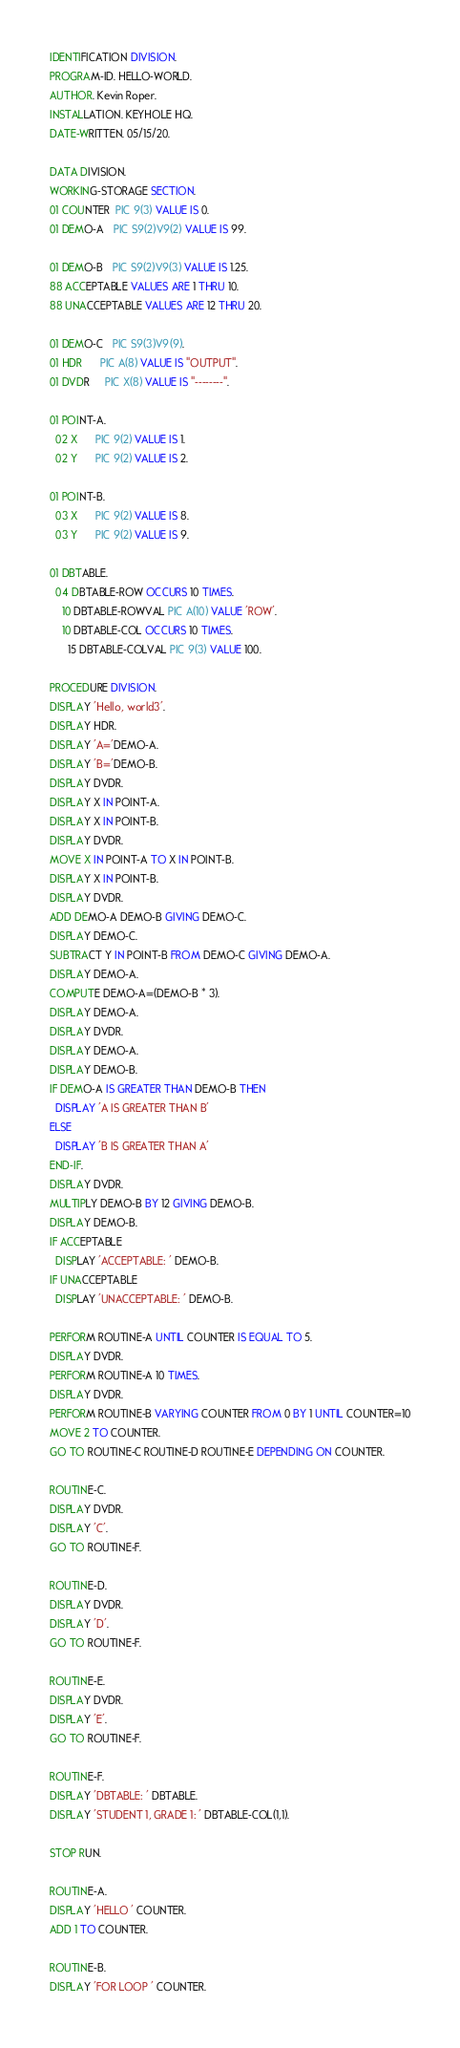Convert code to text. <code><loc_0><loc_0><loc_500><loc_500><_COBOL_>IDENTIFICATION DIVISION.
PROGRAM-ID. HELLO-WORLD.
AUTHOR. Kevin Roper.
INSTALLATION. KEYHOLE HQ.
DATE-WRITTEN. 05/15/20.

DATA DIVISION.
WORKING-STORAGE SECTION.
01 COUNTER  PIC 9(3) VALUE IS 0.
01 DEMO-A   PIC S9(2)V9(2) VALUE IS 99.

01 DEMO-B   PIC S9(2)V9(3) VALUE IS 1.25.
88 ACCEPTABLE VALUES ARE 1 THRU 10.
88 UNACCEPTABLE VALUES ARE 12 THRU 20.

01 DEMO-C   PIC S9(3)V9(9).
01 HDR      PIC A(8) VALUE IS "OUTPUT".
01 DVDR     PIC X(8) VALUE IS "--------".

01 POINT-A.
  02 X      PIC 9(2) VALUE IS 1.
  02 Y      PIC 9(2) VALUE IS 2.

01 POINT-B.
  03 X      PIC 9(2) VALUE IS 8.
  03 Y      PIC 9(2) VALUE IS 9.

01 DBTABLE.
  04 DBTABLE-ROW OCCURS 10 TIMES.
    10 DBTABLE-ROWVAL PIC A(10) VALUE 'ROW'.
    10 DBTABLE-COL OCCURS 10 TIMES.
      15 DBTABLE-COLVAL PIC 9(3) VALUE 100.

PROCEDURE DIVISION.
DISPLAY 'Hello, world3'.
DISPLAY HDR.
DISPLAY 'A='DEMO-A.
DISPLAY 'B='DEMO-B.
DISPLAY DVDR.
DISPLAY X IN POINT-A.
DISPLAY X IN POINT-B.
DISPLAY DVDR.
MOVE X IN POINT-A TO X IN POINT-B.
DISPLAY X IN POINT-B.
DISPLAY DVDR.
ADD DEMO-A DEMO-B GIVING DEMO-C.
DISPLAY DEMO-C.
SUBTRACT Y IN POINT-B FROM DEMO-C GIVING DEMO-A.
DISPLAY DEMO-A.
COMPUTE DEMO-A=(DEMO-B * 3).
DISPLAY DEMO-A.
DISPLAY DVDR.
DISPLAY DEMO-A.
DISPLAY DEMO-B.
IF DEMO-A IS GREATER THAN DEMO-B THEN
  DISPLAY 'A IS GREATER THAN B'
ELSE
  DISPLAY 'B IS GREATER THAN A'
END-IF.
DISPLAY DVDR.
MULTIPLY DEMO-B BY 12 GIVING DEMO-B.
DISPLAY DEMO-B.
IF ACCEPTABLE
  DISPLAY 'ACCEPTABLE: ' DEMO-B.
IF UNACCEPTABLE
  DISPLAY 'UNACCEPTABLE: ' DEMO-B.

PERFORM ROUTINE-A UNTIL COUNTER IS EQUAL TO 5.
DISPLAY DVDR.
PERFORM ROUTINE-A 10 TIMES.
DISPLAY DVDR.
PERFORM ROUTINE-B VARYING COUNTER FROM 0 BY 1 UNTIL COUNTER=10
MOVE 2 TO COUNTER.
GO TO ROUTINE-C ROUTINE-D ROUTINE-E DEPENDING ON COUNTER.

ROUTINE-C.
DISPLAY DVDR.
DISPLAY 'C'.
GO TO ROUTINE-F.

ROUTINE-D.
DISPLAY DVDR.
DISPLAY 'D'.
GO TO ROUTINE-F.

ROUTINE-E.
DISPLAY DVDR.
DISPLAY 'E'.
GO TO ROUTINE-F.

ROUTINE-F.
DISPLAY 'DBTABLE: ' DBTABLE.
DISPLAY 'STUDENT 1, GRADE 1: ' DBTABLE-COL(1,1).

STOP RUN.

ROUTINE-A.
DISPLAY 'HELLO ' COUNTER.
ADD 1 TO COUNTER.

ROUTINE-B.
DISPLAY 'FOR LOOP ' COUNTER.
</code> 